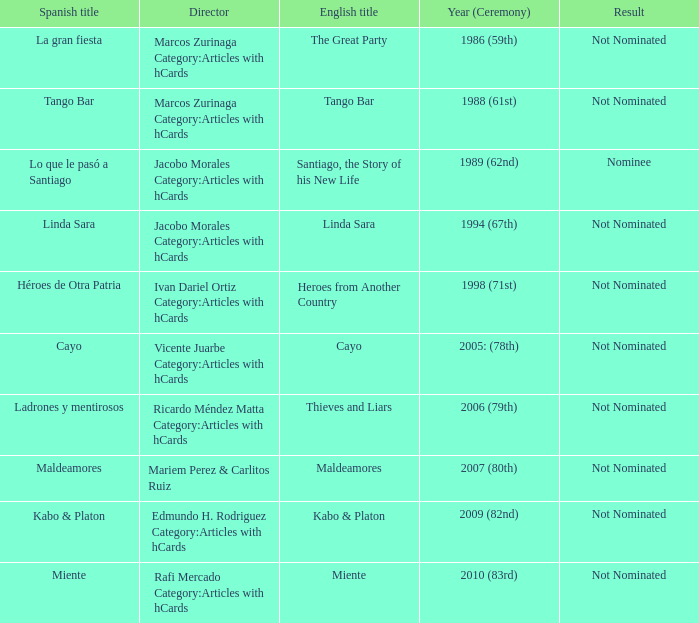What was the English title of Ladrones Y Mentirosos? Thieves and Liars. 